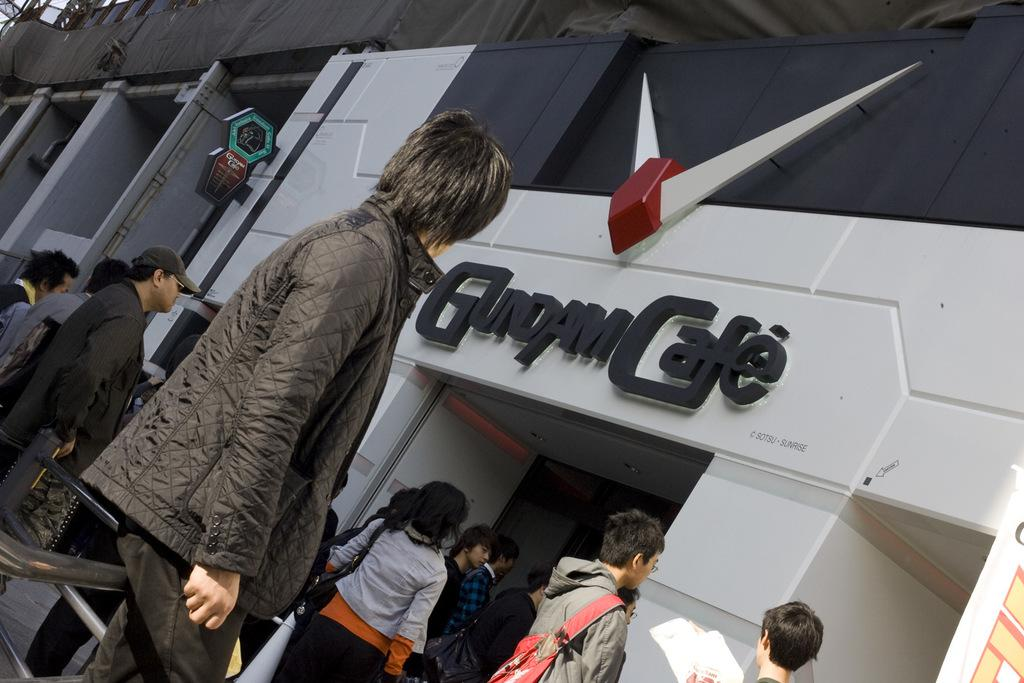Who or what can be seen in the image? There are people in the image. What else is present in the image besides people? There are buildings in the image. Can you describe the buildings in the image? The buildings have names on them. Are there any additional features on the buildings? Yes, there are objects attached to the buildings. Where is the nest located in the image? There is no nest present in the image. What type of paper can be seen in the image? There is no paper present in the image. 